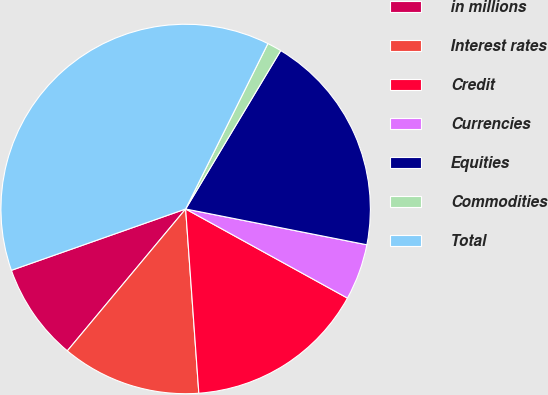Convert chart to OTSL. <chart><loc_0><loc_0><loc_500><loc_500><pie_chart><fcel>in millions<fcel>Interest rates<fcel>Credit<fcel>Currencies<fcel>Equities<fcel>Commodities<fcel>Total<nl><fcel>8.55%<fcel>12.2%<fcel>15.85%<fcel>4.91%<fcel>19.5%<fcel>1.26%<fcel>37.73%<nl></chart> 